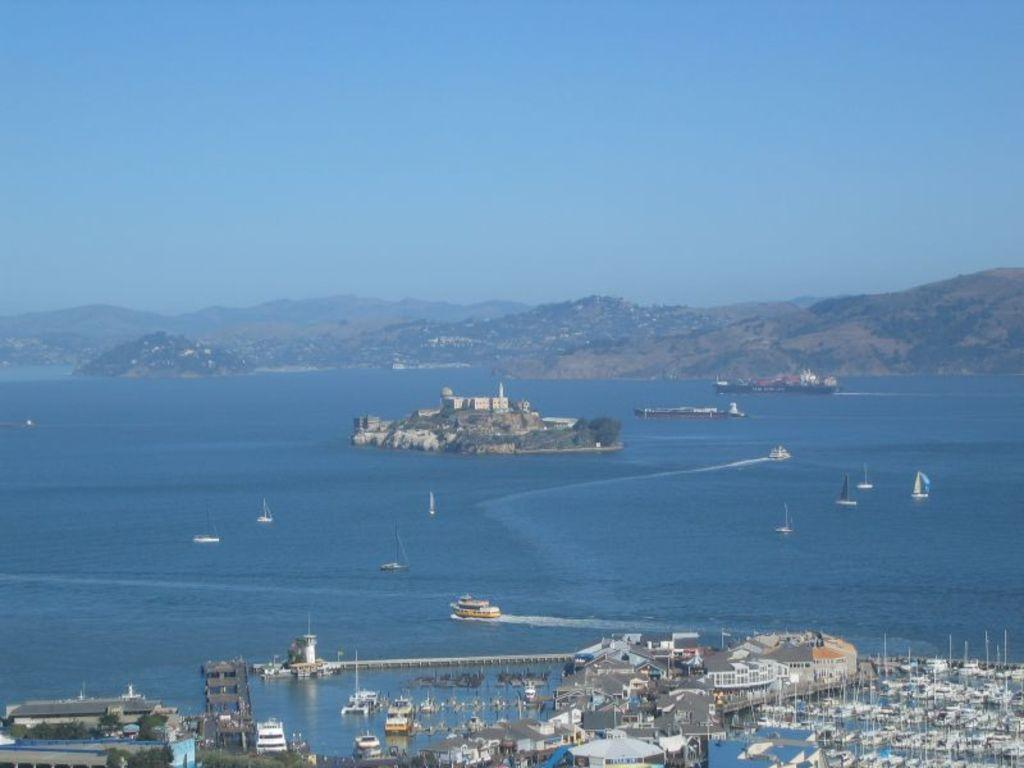What is the main subject of the image? The main subject of the image is a ship. What part of the ship can be seen in the image? The ship's bridge railing is visible in the image. What is the setting of the image? The image features water, houses, trees, hills, and the sky. What type of meal is being served on the sidewalk in the image? There is no sidewalk or meal present in the image; it features a ship in a setting with water, houses, trees, hills, and the sky. 